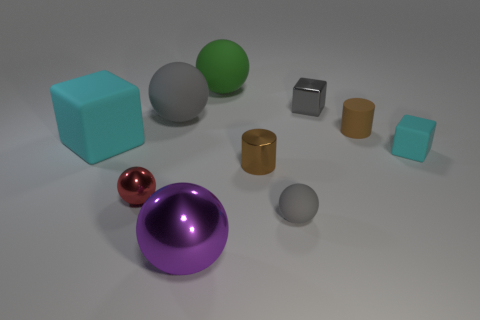Is there any other thing that has the same color as the large metal object?
Provide a succinct answer. No. What is the size of the green ball that is made of the same material as the large block?
Your answer should be compact. Large. Do the red metal ball and the gray metal object have the same size?
Your answer should be very brief. Yes. Are there any tiny red shiny cylinders?
Your answer should be compact. No. What size is the other ball that is the same color as the tiny rubber sphere?
Offer a very short reply. Large. What is the size of the gray sphere that is behind the cyan object left of the small brown cylinder in front of the small cyan block?
Offer a very short reply. Large. What number of big cubes are made of the same material as the tiny cyan cube?
Ensure brevity in your answer.  1. What number of red things are the same size as the red shiny sphere?
Provide a succinct answer. 0. What is the material of the tiny brown cylinder behind the cyan block behind the cyan rubber cube to the right of the big green object?
Ensure brevity in your answer.  Rubber. How many things are big cyan things or small brown shiny cylinders?
Provide a short and direct response. 2. 